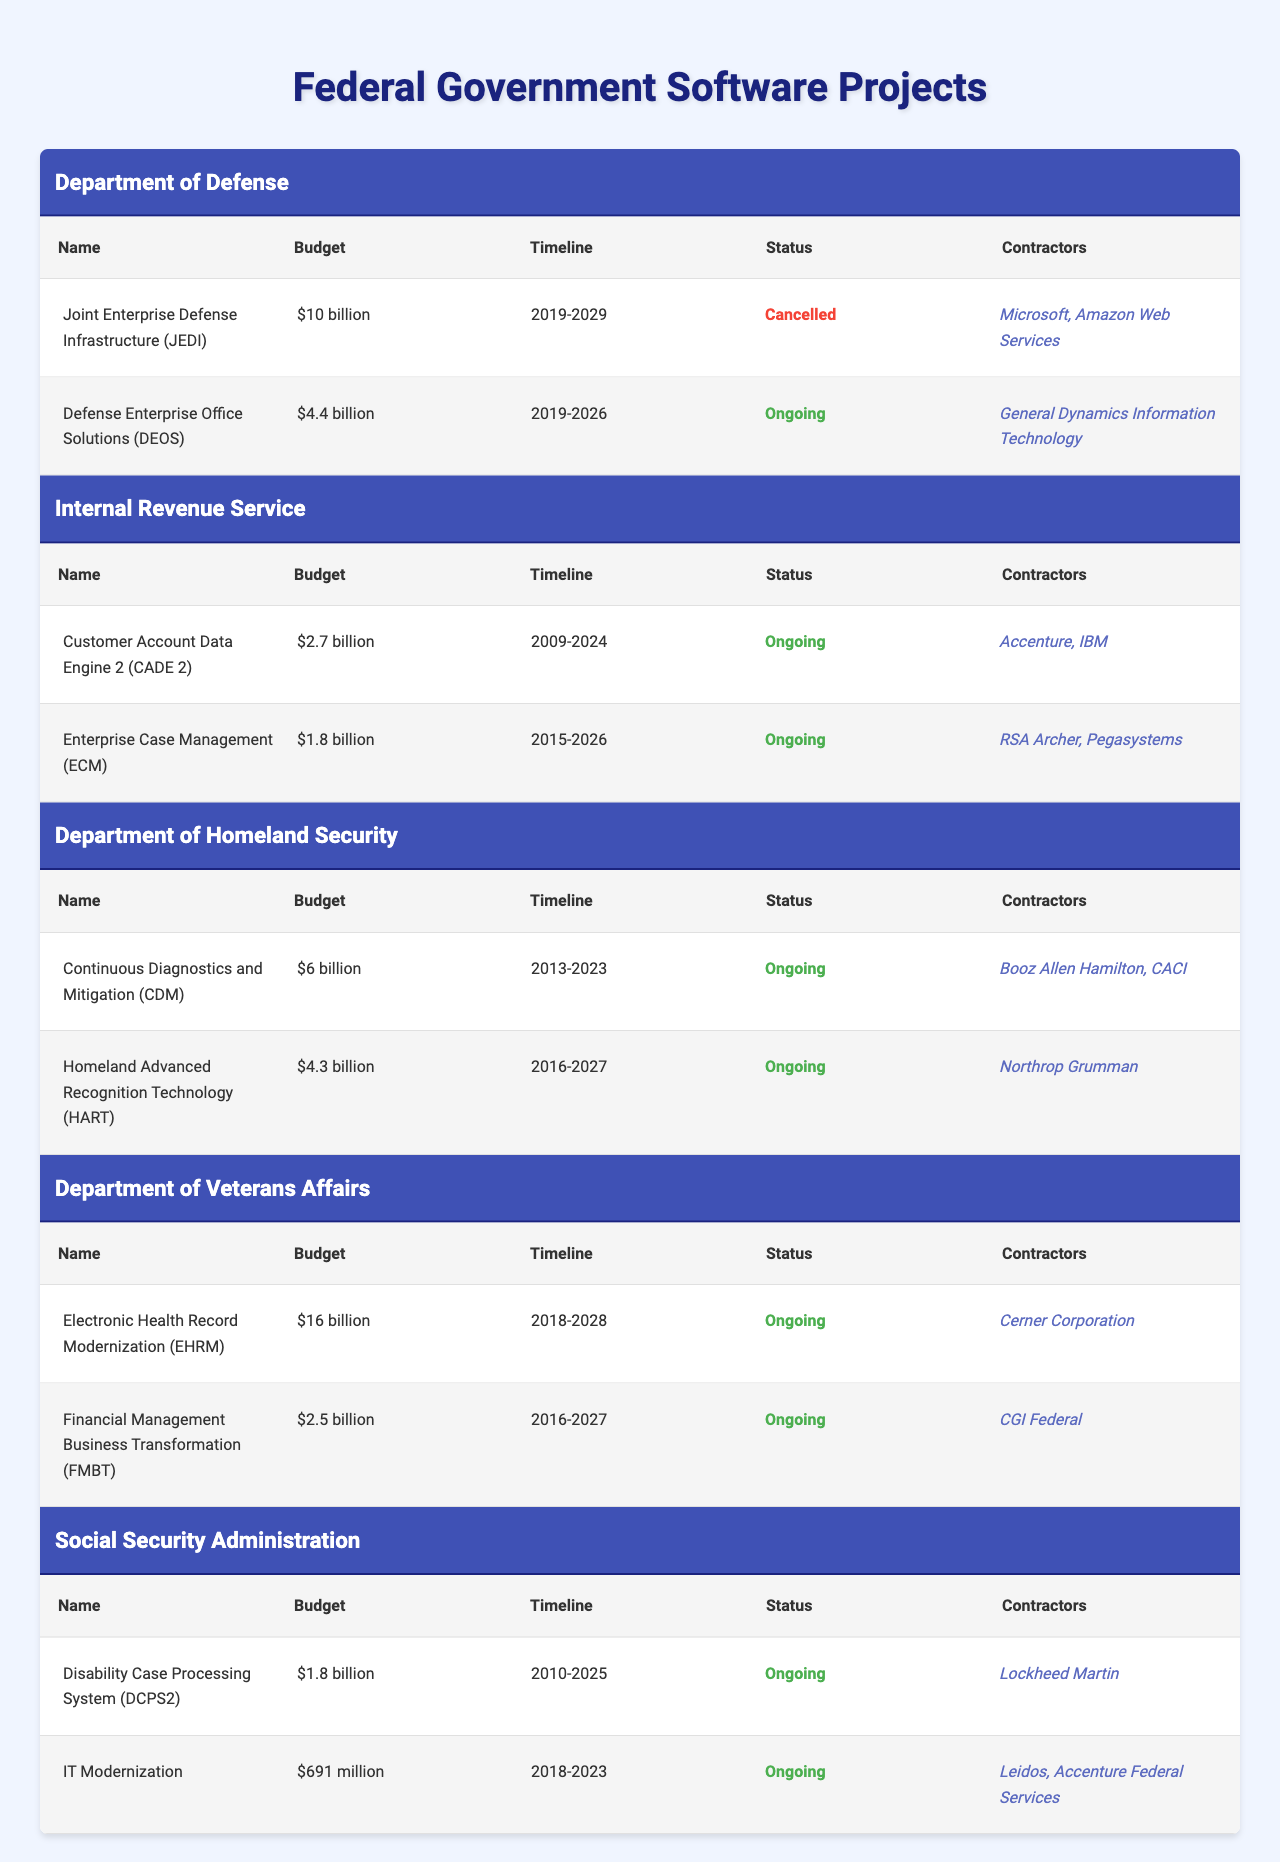What is the total budget for projects under the Department of Defense? The budget for the Joint Enterprise Defense Infrastructure (JEDI) is $10 billion and for the Defense Enterprise Office Solutions (DEOS) it is $4.4 billion. Adding both budgets gives a total of $10 billion + $4.4 billion = $14.4 billion.
Answer: $14.4 billion Which project has the longest timeline? The project with the longest timeline is the Electronic Health Record Modernization (EHRM) from the Department of Veterans Affairs, which runs from 2018 to 2028. This gives it a total duration of 10 years.
Answer: Electronic Health Record Modernization (EHRM) Is the Enterprise Case Management (ECM) project ongoing? The Enterprise Case Management (ECM) project is marked as ongoing according to the status column in the table.
Answer: Yes How many projects have a budget of over $5 billion? There are three projects with budgets over $5 billion: Joint Enterprise Defense Infrastructure (JEDI) - $10 billion, Continuous Diagnostics and Mitigation (CDM) - $6 billion, and Electronic Health Record Modernization (EHRM) - $16 billion, totaling three projects.
Answer: 3 Which agency has the highest total project budget? The Department of Veterans Affairs has the highest total budget when considering both projects: Electronic Health Record Modernization (EHRM) at $16 billion and Financial Management Business Transformation (FMBT) at $2.5 billion, totaling $18.5 billion.
Answer: Department of Veterans Affairs What is the average budget of projects under the Internal Revenue Service? The Internal Revenue Service has two projects: CADE 2 with a budget of $2.7 billion and ECM with a budget of $1.8 billion. The total budget is $2.7 billion + $1.8 billion = $4.5 billion. Dividing by 2 gives an average of $4.5 billion / 2 = $2.25 billion.
Answer: $2.25 billion How many contractors are involved in the Continuous Diagnostics and Mitigation (CDM) project? The Continuous Diagnostics and Mitigation (CDM) project has two contractors listed: Booz Allen Hamilton and CACI.
Answer: 2 Is the budget for the Disability Case Processing System (DCPS2) greater than that of IT Modernization? The budget for Disability Case Processing System (DCPS2) is $1.8 billion, while the budget for IT Modernization is $691 million. Since $1.8 billion is greater than $691 million, the statement is true.
Answer: Yes What is the total number of ongoing projects across all agencies? By examining the table, the ongoing projects are DEOS (DoD), CADE 2 (IRS), ECM (IRS), CDM (DHS), HART (DHS), EHRM (VA), FMBT (VA), DCPS2 (SSA), and IT Modernization (SSA). Counting these gives a total of 9 ongoing projects.
Answer: 9 Do any projects from the Department of Homeland Security share contractors? The projects from the Department of Homeland Security, Continuous Diagnostics and Mitigation (CDM) and Homeland Advanced Recognition Technology (HART), have different contractors. CDM has Booz Allen Hamilton and CACI while HART has Northrop Grumman. Therefore, there are no shared contractors.
Answer: No 